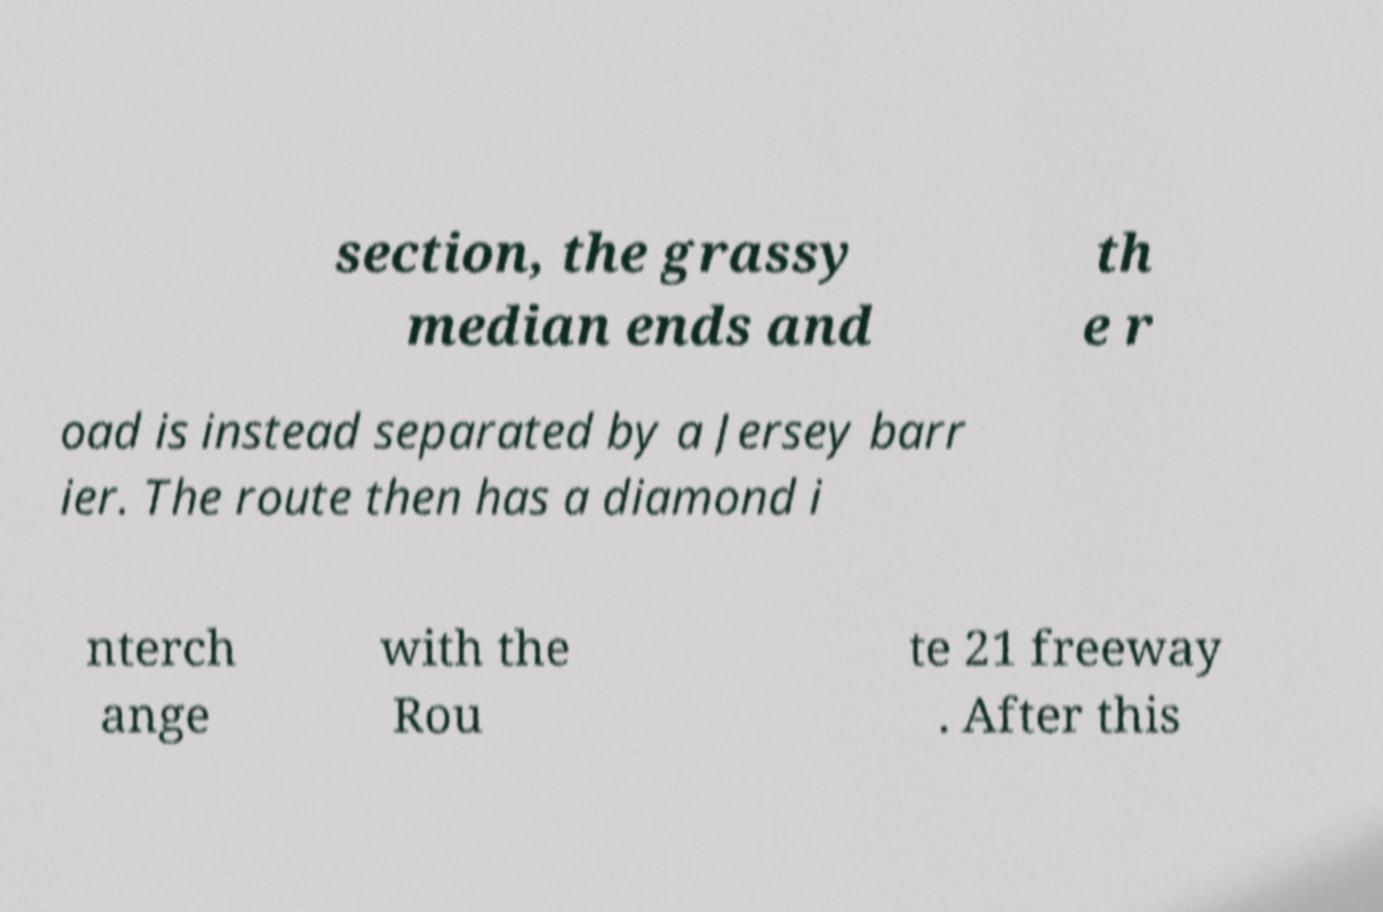What messages or text are displayed in this image? I need them in a readable, typed format. section, the grassy median ends and th e r oad is instead separated by a Jersey barr ier. The route then has a diamond i nterch ange with the Rou te 21 freeway . After this 